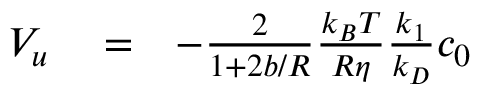Convert formula to latex. <formula><loc_0><loc_0><loc_500><loc_500>\begin{array} { r l r } { V _ { u } } & = } & { - \frac { 2 } { 1 + 2 b / R } \frac { k _ { B } T } { R \eta } \frac { k _ { 1 } } { k _ { D } } c _ { 0 } } \end{array}</formula> 